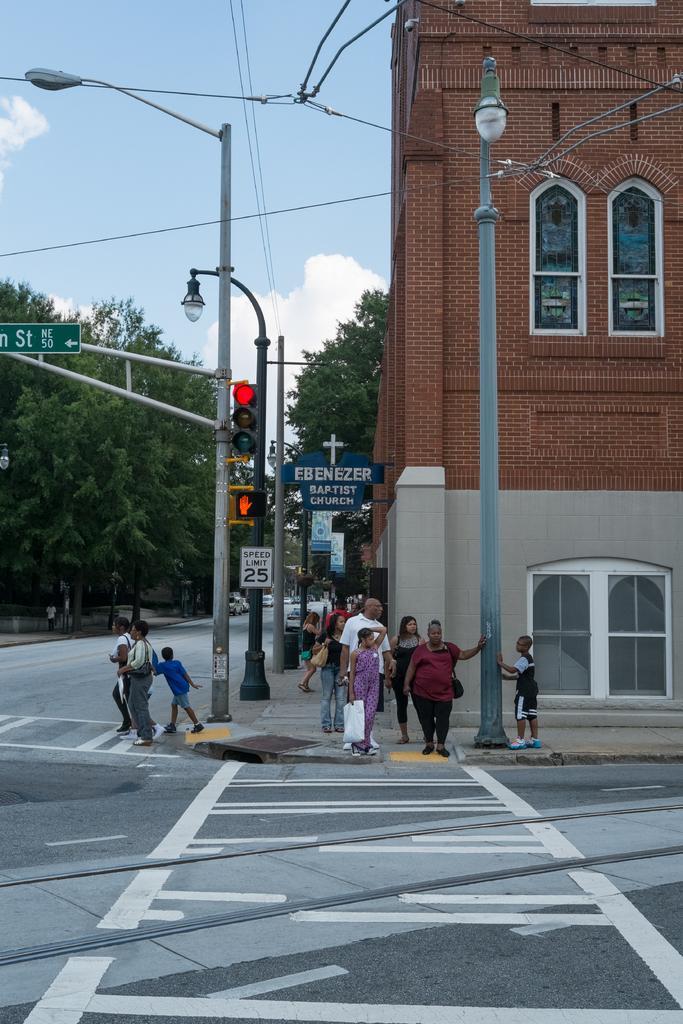Can you describe this image briefly? In this image we can see light poles, traffic signals and sign boards to the pole. Here we can see these people are crossing the road on the zebra crossing and these people are standing on the side walk. In the background, we can see brick building, trees and sky with clouds. 